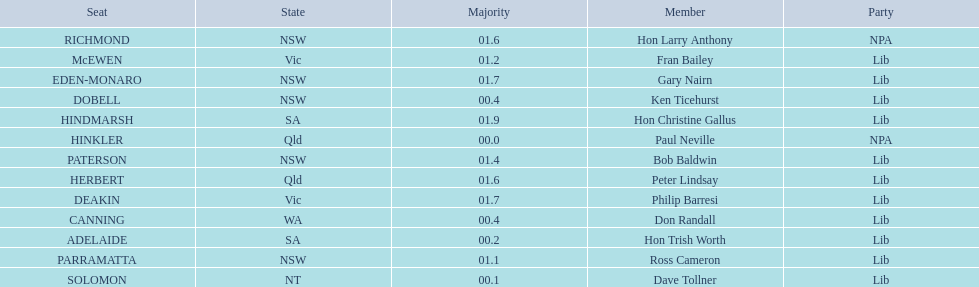How many states were included in the seats? 6. 